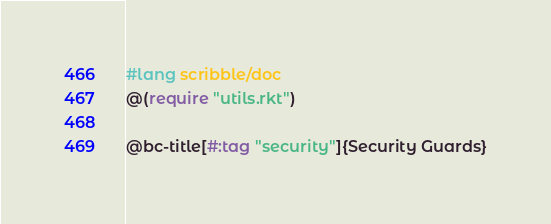<code> <loc_0><loc_0><loc_500><loc_500><_Racket_>#lang scribble/doc
@(require "utils.rkt")

@bc-title[#:tag "security"]{Security Guards}
</code> 